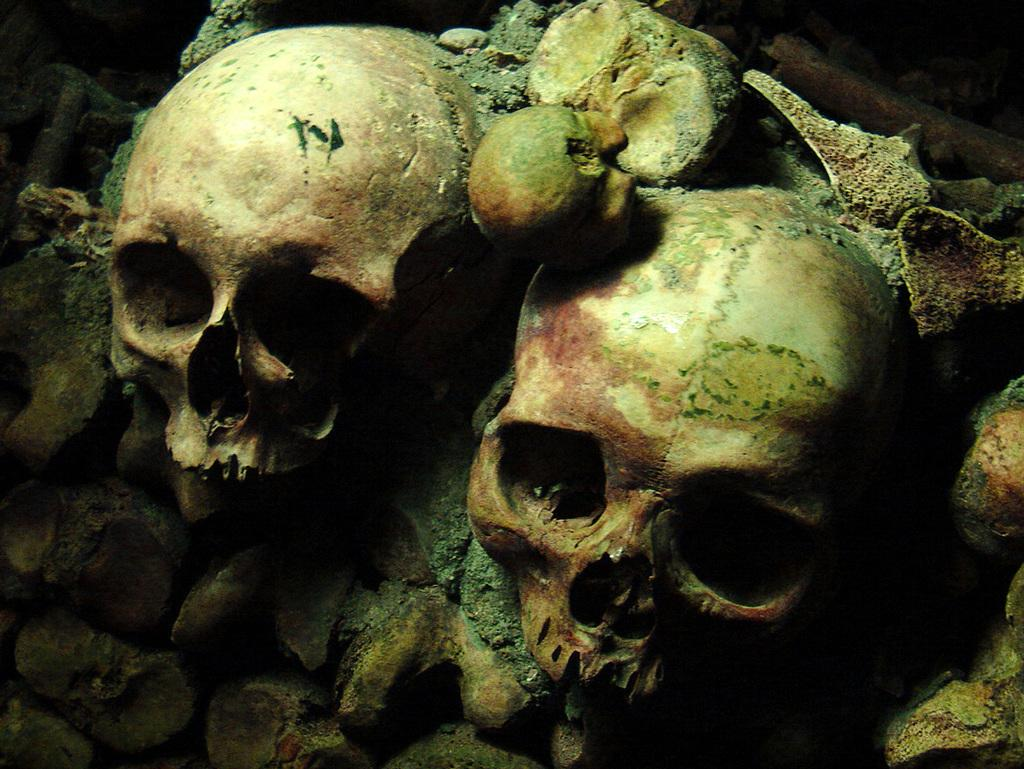What type of objects can be seen in the image? There are skulls in the image. Can you describe any other objects present in the image besides the skulls? Unfortunately, the provided facts only mention the presence of skulls, so we cannot describe any other objects in the image. What type of camera can be seen in the image? There is no camera present in the image. Can you describe the town in the background of the image? There is no town or background mentioned in the provided facts, so we cannot describe any town or background in the image. 